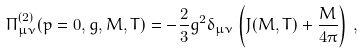Convert formula to latex. <formula><loc_0><loc_0><loc_500><loc_500>\Pi _ { \mu \nu } ^ { ( 2 ) } ( p = 0 , g , M , T ) = - \frac { 2 } { 3 } g ^ { 2 } \delta _ { \mu \nu } \left ( J ( M , T ) + \frac { M } { 4 \pi } \right ) \, ,</formula> 